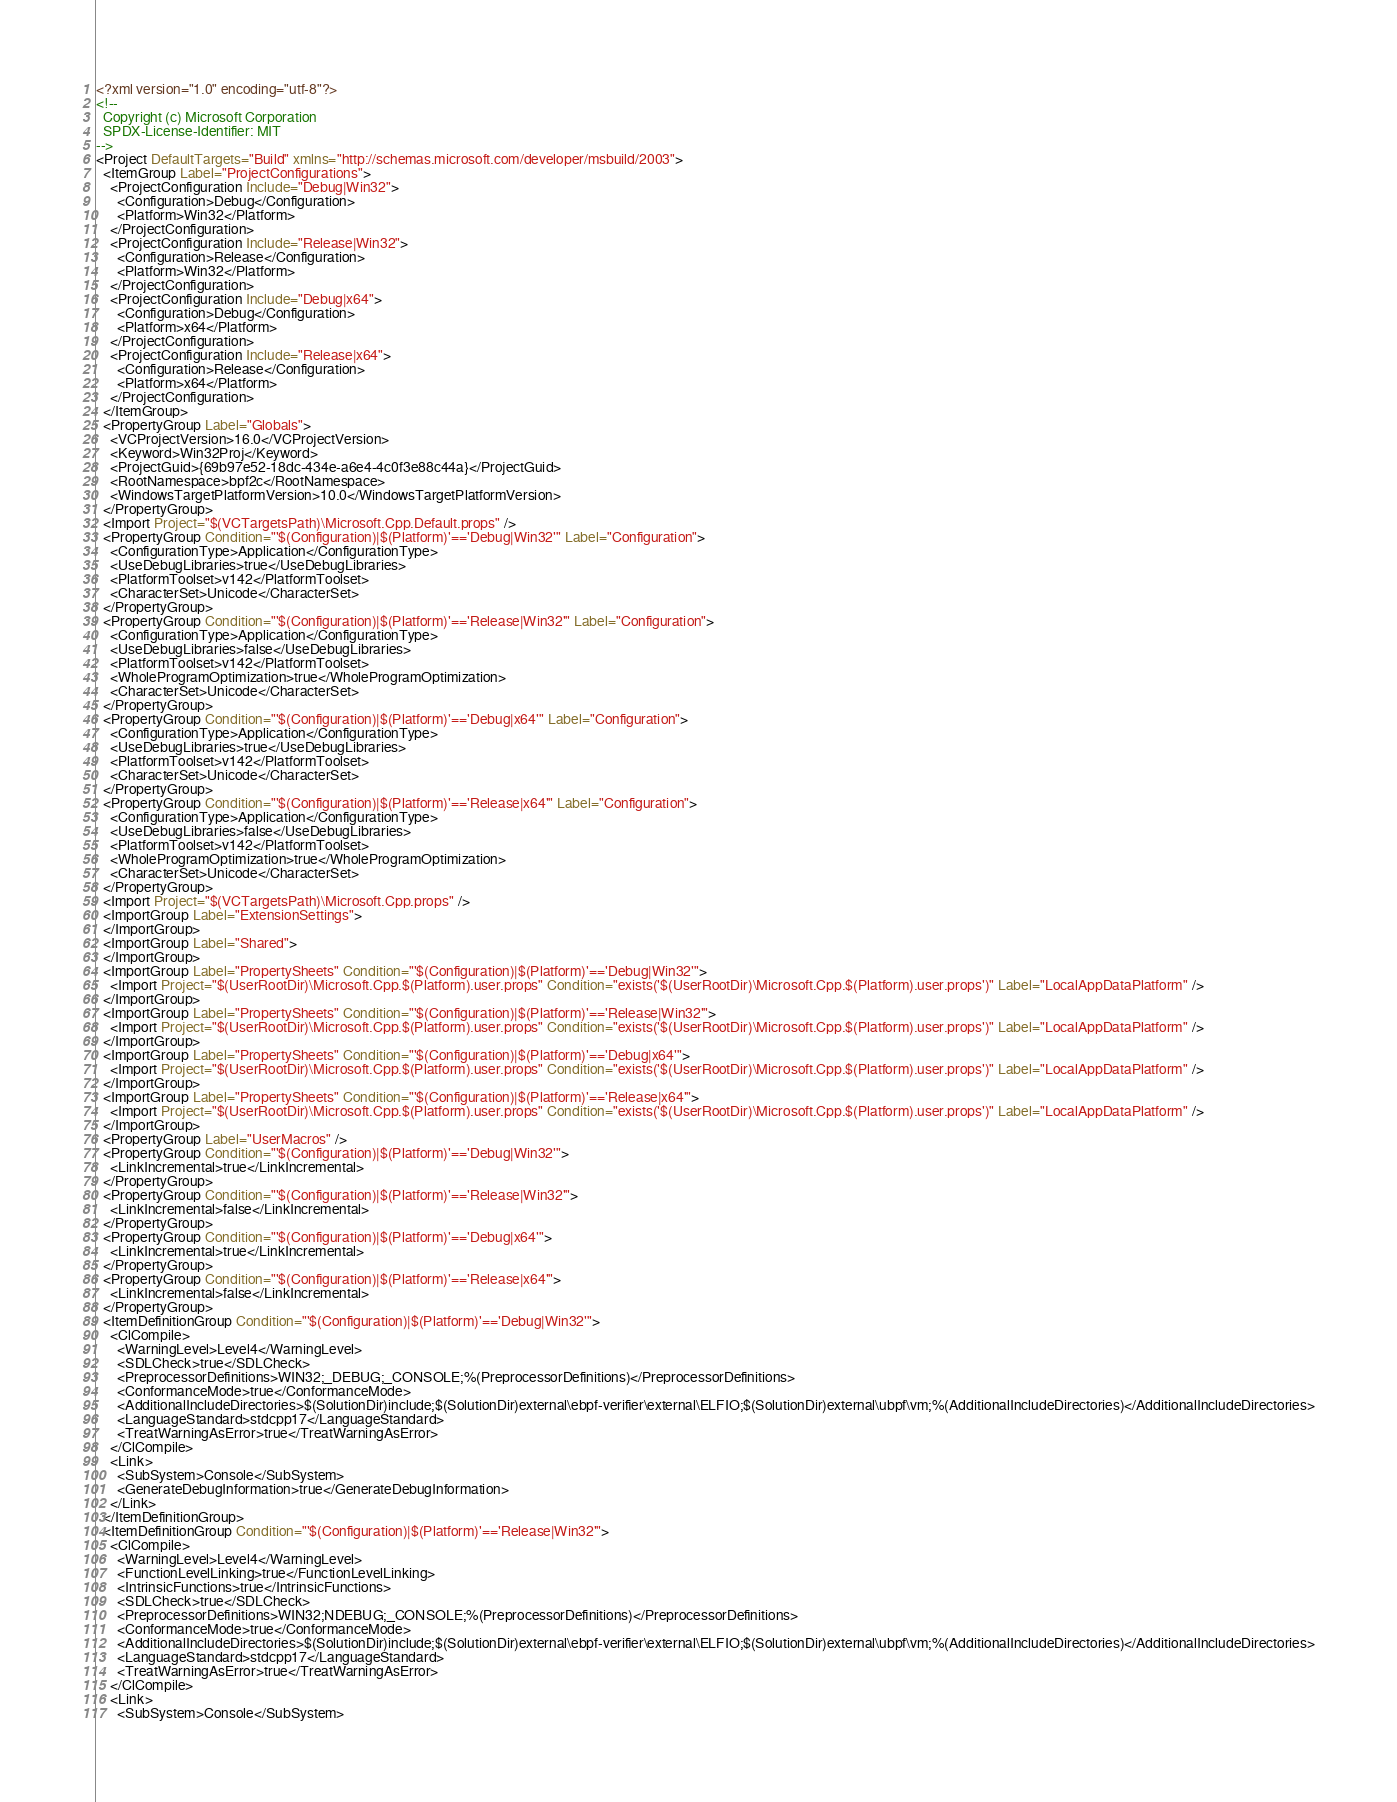<code> <loc_0><loc_0><loc_500><loc_500><_XML_><?xml version="1.0" encoding="utf-8"?>
<!--
  Copyright (c) Microsoft Corporation
  SPDX-License-Identifier: MIT
-->
<Project DefaultTargets="Build" xmlns="http://schemas.microsoft.com/developer/msbuild/2003">
  <ItemGroup Label="ProjectConfigurations">
    <ProjectConfiguration Include="Debug|Win32">
      <Configuration>Debug</Configuration>
      <Platform>Win32</Platform>
    </ProjectConfiguration>
    <ProjectConfiguration Include="Release|Win32">
      <Configuration>Release</Configuration>
      <Platform>Win32</Platform>
    </ProjectConfiguration>
    <ProjectConfiguration Include="Debug|x64">
      <Configuration>Debug</Configuration>
      <Platform>x64</Platform>
    </ProjectConfiguration>
    <ProjectConfiguration Include="Release|x64">
      <Configuration>Release</Configuration>
      <Platform>x64</Platform>
    </ProjectConfiguration>
  </ItemGroup>
  <PropertyGroup Label="Globals">
    <VCProjectVersion>16.0</VCProjectVersion>
    <Keyword>Win32Proj</Keyword>
    <ProjectGuid>{69b97e52-18dc-434e-a6e4-4c0f3e88c44a}</ProjectGuid>
    <RootNamespace>bpf2c</RootNamespace>
    <WindowsTargetPlatformVersion>10.0</WindowsTargetPlatformVersion>
  </PropertyGroup>
  <Import Project="$(VCTargetsPath)\Microsoft.Cpp.Default.props" />
  <PropertyGroup Condition="'$(Configuration)|$(Platform)'=='Debug|Win32'" Label="Configuration">
    <ConfigurationType>Application</ConfigurationType>
    <UseDebugLibraries>true</UseDebugLibraries>
    <PlatformToolset>v142</PlatformToolset>
    <CharacterSet>Unicode</CharacterSet>
  </PropertyGroup>
  <PropertyGroup Condition="'$(Configuration)|$(Platform)'=='Release|Win32'" Label="Configuration">
    <ConfigurationType>Application</ConfigurationType>
    <UseDebugLibraries>false</UseDebugLibraries>
    <PlatformToolset>v142</PlatformToolset>
    <WholeProgramOptimization>true</WholeProgramOptimization>
    <CharacterSet>Unicode</CharacterSet>
  </PropertyGroup>
  <PropertyGroup Condition="'$(Configuration)|$(Platform)'=='Debug|x64'" Label="Configuration">
    <ConfigurationType>Application</ConfigurationType>
    <UseDebugLibraries>true</UseDebugLibraries>
    <PlatformToolset>v142</PlatformToolset>
    <CharacterSet>Unicode</CharacterSet>
  </PropertyGroup>
  <PropertyGroup Condition="'$(Configuration)|$(Platform)'=='Release|x64'" Label="Configuration">
    <ConfigurationType>Application</ConfigurationType>
    <UseDebugLibraries>false</UseDebugLibraries>
    <PlatformToolset>v142</PlatformToolset>
    <WholeProgramOptimization>true</WholeProgramOptimization>
    <CharacterSet>Unicode</CharacterSet>
  </PropertyGroup>
  <Import Project="$(VCTargetsPath)\Microsoft.Cpp.props" />
  <ImportGroup Label="ExtensionSettings">
  </ImportGroup>
  <ImportGroup Label="Shared">
  </ImportGroup>
  <ImportGroup Label="PropertySheets" Condition="'$(Configuration)|$(Platform)'=='Debug|Win32'">
    <Import Project="$(UserRootDir)\Microsoft.Cpp.$(Platform).user.props" Condition="exists('$(UserRootDir)\Microsoft.Cpp.$(Platform).user.props')" Label="LocalAppDataPlatform" />
  </ImportGroup>
  <ImportGroup Label="PropertySheets" Condition="'$(Configuration)|$(Platform)'=='Release|Win32'">
    <Import Project="$(UserRootDir)\Microsoft.Cpp.$(Platform).user.props" Condition="exists('$(UserRootDir)\Microsoft.Cpp.$(Platform).user.props')" Label="LocalAppDataPlatform" />
  </ImportGroup>
  <ImportGroup Label="PropertySheets" Condition="'$(Configuration)|$(Platform)'=='Debug|x64'">
    <Import Project="$(UserRootDir)\Microsoft.Cpp.$(Platform).user.props" Condition="exists('$(UserRootDir)\Microsoft.Cpp.$(Platform).user.props')" Label="LocalAppDataPlatform" />
  </ImportGroup>
  <ImportGroup Label="PropertySheets" Condition="'$(Configuration)|$(Platform)'=='Release|x64'">
    <Import Project="$(UserRootDir)\Microsoft.Cpp.$(Platform).user.props" Condition="exists('$(UserRootDir)\Microsoft.Cpp.$(Platform).user.props')" Label="LocalAppDataPlatform" />
  </ImportGroup>
  <PropertyGroup Label="UserMacros" />
  <PropertyGroup Condition="'$(Configuration)|$(Platform)'=='Debug|Win32'">
    <LinkIncremental>true</LinkIncremental>
  </PropertyGroup>
  <PropertyGroup Condition="'$(Configuration)|$(Platform)'=='Release|Win32'">
    <LinkIncremental>false</LinkIncremental>
  </PropertyGroup>
  <PropertyGroup Condition="'$(Configuration)|$(Platform)'=='Debug|x64'">
    <LinkIncremental>true</LinkIncremental>
  </PropertyGroup>
  <PropertyGroup Condition="'$(Configuration)|$(Platform)'=='Release|x64'">
    <LinkIncremental>false</LinkIncremental>
  </PropertyGroup>
  <ItemDefinitionGroup Condition="'$(Configuration)|$(Platform)'=='Debug|Win32'">
    <ClCompile>
      <WarningLevel>Level4</WarningLevel>
      <SDLCheck>true</SDLCheck>
      <PreprocessorDefinitions>WIN32;_DEBUG;_CONSOLE;%(PreprocessorDefinitions)</PreprocessorDefinitions>
      <ConformanceMode>true</ConformanceMode>
      <AdditionalIncludeDirectories>$(SolutionDir)include;$(SolutionDir)external\ebpf-verifier\external\ELFIO;$(SolutionDir)external\ubpf\vm;%(AdditionalIncludeDirectories)</AdditionalIncludeDirectories>
      <LanguageStandard>stdcpp17</LanguageStandard>
      <TreatWarningAsError>true</TreatWarningAsError>
    </ClCompile>
    <Link>
      <SubSystem>Console</SubSystem>
      <GenerateDebugInformation>true</GenerateDebugInformation>
    </Link>
  </ItemDefinitionGroup>
  <ItemDefinitionGroup Condition="'$(Configuration)|$(Platform)'=='Release|Win32'">
    <ClCompile>
      <WarningLevel>Level4</WarningLevel>
      <FunctionLevelLinking>true</FunctionLevelLinking>
      <IntrinsicFunctions>true</IntrinsicFunctions>
      <SDLCheck>true</SDLCheck>
      <PreprocessorDefinitions>WIN32;NDEBUG;_CONSOLE;%(PreprocessorDefinitions)</PreprocessorDefinitions>
      <ConformanceMode>true</ConformanceMode>
      <AdditionalIncludeDirectories>$(SolutionDir)include;$(SolutionDir)external\ebpf-verifier\external\ELFIO;$(SolutionDir)external\ubpf\vm;%(AdditionalIncludeDirectories)</AdditionalIncludeDirectories>
      <LanguageStandard>stdcpp17</LanguageStandard>
      <TreatWarningAsError>true</TreatWarningAsError>
    </ClCompile>
    <Link>
      <SubSystem>Console</SubSystem></code> 